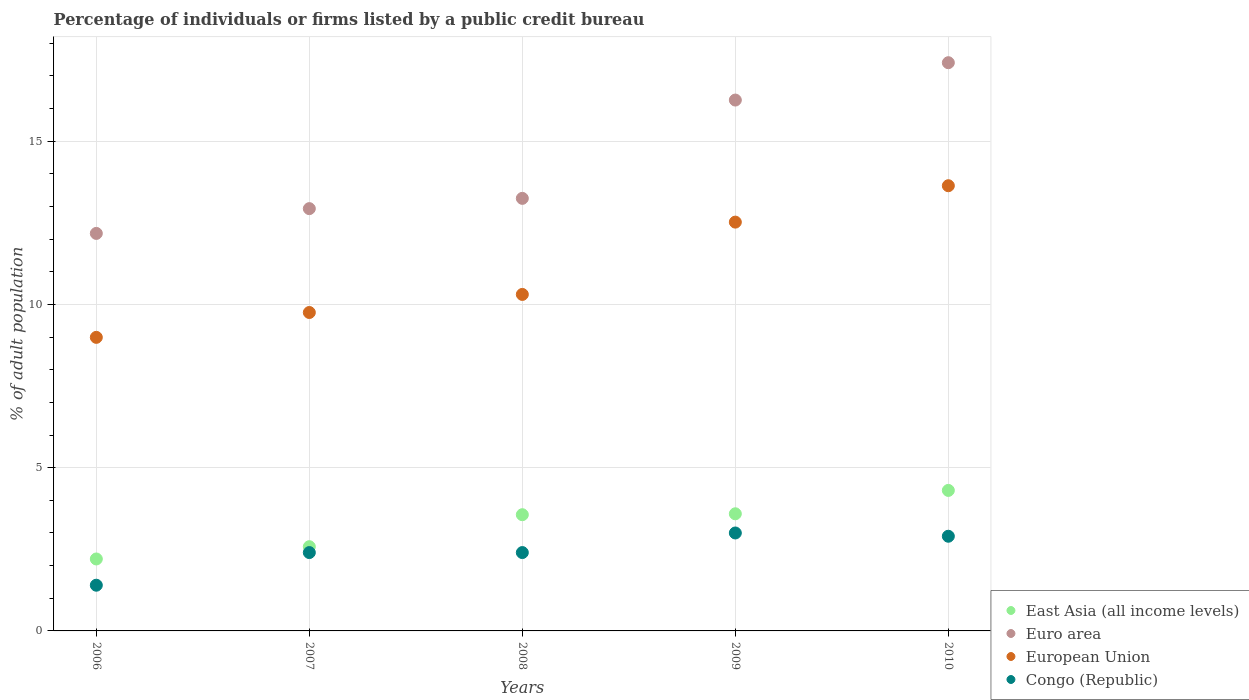What is the percentage of population listed by a public credit bureau in Euro area in 2006?
Offer a terse response. 12.18. Across all years, what is the maximum percentage of population listed by a public credit bureau in Euro area?
Your answer should be very brief. 17.41. In which year was the percentage of population listed by a public credit bureau in East Asia (all income levels) minimum?
Offer a terse response. 2006. What is the total percentage of population listed by a public credit bureau in East Asia (all income levels) in the graph?
Offer a terse response. 16.24. What is the difference between the percentage of population listed by a public credit bureau in Congo (Republic) in 2008 and that in 2010?
Provide a short and direct response. -0.5. What is the difference between the percentage of population listed by a public credit bureau in Congo (Republic) in 2006 and the percentage of population listed by a public credit bureau in European Union in 2008?
Offer a terse response. -8.91. What is the average percentage of population listed by a public credit bureau in European Union per year?
Your response must be concise. 11.04. In the year 2010, what is the difference between the percentage of population listed by a public credit bureau in East Asia (all income levels) and percentage of population listed by a public credit bureau in European Union?
Your answer should be very brief. -9.33. In how many years, is the percentage of population listed by a public credit bureau in Euro area greater than 12 %?
Your response must be concise. 5. What is the ratio of the percentage of population listed by a public credit bureau in Congo (Republic) in 2008 to that in 2010?
Make the answer very short. 0.83. What is the difference between the highest and the second highest percentage of population listed by a public credit bureau in Euro area?
Your answer should be very brief. 1.14. What is the difference between the highest and the lowest percentage of population listed by a public credit bureau in European Union?
Offer a very short reply. 4.64. Is it the case that in every year, the sum of the percentage of population listed by a public credit bureau in European Union and percentage of population listed by a public credit bureau in Euro area  is greater than the sum of percentage of population listed by a public credit bureau in Congo (Republic) and percentage of population listed by a public credit bureau in East Asia (all income levels)?
Provide a succinct answer. No. Is the percentage of population listed by a public credit bureau in European Union strictly less than the percentage of population listed by a public credit bureau in Euro area over the years?
Offer a terse response. Yes. What is the difference between two consecutive major ticks on the Y-axis?
Offer a terse response. 5. Are the values on the major ticks of Y-axis written in scientific E-notation?
Ensure brevity in your answer.  No. Does the graph contain any zero values?
Provide a succinct answer. No. Does the graph contain grids?
Keep it short and to the point. Yes. How many legend labels are there?
Offer a terse response. 4. What is the title of the graph?
Offer a very short reply. Percentage of individuals or firms listed by a public credit bureau. Does "Serbia" appear as one of the legend labels in the graph?
Make the answer very short. No. What is the label or title of the Y-axis?
Make the answer very short. % of adult population. What is the % of adult population of East Asia (all income levels) in 2006?
Your response must be concise. 2.2. What is the % of adult population of Euro area in 2006?
Provide a succinct answer. 12.18. What is the % of adult population of European Union in 2006?
Offer a terse response. 8.99. What is the % of adult population in East Asia (all income levels) in 2007?
Keep it short and to the point. 2.58. What is the % of adult population in Euro area in 2007?
Your response must be concise. 12.94. What is the % of adult population in European Union in 2007?
Ensure brevity in your answer.  9.75. What is the % of adult population in Congo (Republic) in 2007?
Offer a terse response. 2.4. What is the % of adult population of East Asia (all income levels) in 2008?
Keep it short and to the point. 3.56. What is the % of adult population in Euro area in 2008?
Offer a very short reply. 13.25. What is the % of adult population in European Union in 2008?
Your response must be concise. 10.31. What is the % of adult population in Congo (Republic) in 2008?
Your answer should be very brief. 2.4. What is the % of adult population of East Asia (all income levels) in 2009?
Provide a short and direct response. 3.59. What is the % of adult population in Euro area in 2009?
Offer a very short reply. 16.26. What is the % of adult population in European Union in 2009?
Make the answer very short. 12.52. What is the % of adult population in Congo (Republic) in 2009?
Offer a terse response. 3. What is the % of adult population of East Asia (all income levels) in 2010?
Keep it short and to the point. 4.3. What is the % of adult population of Euro area in 2010?
Provide a short and direct response. 17.41. What is the % of adult population of European Union in 2010?
Keep it short and to the point. 13.64. Across all years, what is the maximum % of adult population in East Asia (all income levels)?
Your response must be concise. 4.3. Across all years, what is the maximum % of adult population of Euro area?
Keep it short and to the point. 17.41. Across all years, what is the maximum % of adult population in European Union?
Provide a succinct answer. 13.64. Across all years, what is the minimum % of adult population in East Asia (all income levels)?
Offer a terse response. 2.2. Across all years, what is the minimum % of adult population in Euro area?
Your answer should be very brief. 12.18. Across all years, what is the minimum % of adult population in European Union?
Offer a very short reply. 8.99. Across all years, what is the minimum % of adult population of Congo (Republic)?
Make the answer very short. 1.4. What is the total % of adult population in East Asia (all income levels) in the graph?
Ensure brevity in your answer.  16.24. What is the total % of adult population in Euro area in the graph?
Provide a short and direct response. 72.03. What is the total % of adult population of European Union in the graph?
Offer a terse response. 55.21. What is the total % of adult population in Congo (Republic) in the graph?
Offer a very short reply. 12.1. What is the difference between the % of adult population of East Asia (all income levels) in 2006 and that in 2007?
Provide a short and direct response. -0.38. What is the difference between the % of adult population of Euro area in 2006 and that in 2007?
Your answer should be very brief. -0.76. What is the difference between the % of adult population in European Union in 2006 and that in 2007?
Provide a short and direct response. -0.76. What is the difference between the % of adult population in East Asia (all income levels) in 2006 and that in 2008?
Provide a succinct answer. -1.36. What is the difference between the % of adult population in Euro area in 2006 and that in 2008?
Provide a succinct answer. -1.07. What is the difference between the % of adult population in European Union in 2006 and that in 2008?
Give a very brief answer. -1.32. What is the difference between the % of adult population in East Asia (all income levels) in 2006 and that in 2009?
Provide a succinct answer. -1.38. What is the difference between the % of adult population in Euro area in 2006 and that in 2009?
Offer a very short reply. -4.08. What is the difference between the % of adult population in European Union in 2006 and that in 2009?
Your answer should be very brief. -3.53. What is the difference between the % of adult population in Congo (Republic) in 2006 and that in 2009?
Your answer should be compact. -1.6. What is the difference between the % of adult population in Euro area in 2006 and that in 2010?
Offer a very short reply. -5.23. What is the difference between the % of adult population of European Union in 2006 and that in 2010?
Ensure brevity in your answer.  -4.64. What is the difference between the % of adult population of Congo (Republic) in 2006 and that in 2010?
Provide a succinct answer. -1.5. What is the difference between the % of adult population of East Asia (all income levels) in 2007 and that in 2008?
Give a very brief answer. -0.98. What is the difference between the % of adult population in Euro area in 2007 and that in 2008?
Offer a very short reply. -0.31. What is the difference between the % of adult population of European Union in 2007 and that in 2008?
Your answer should be compact. -0.55. What is the difference between the % of adult population of East Asia (all income levels) in 2007 and that in 2009?
Your response must be concise. -1.01. What is the difference between the % of adult population in Euro area in 2007 and that in 2009?
Keep it short and to the point. -3.33. What is the difference between the % of adult population of European Union in 2007 and that in 2009?
Give a very brief answer. -2.77. What is the difference between the % of adult population in Congo (Republic) in 2007 and that in 2009?
Make the answer very short. -0.6. What is the difference between the % of adult population of East Asia (all income levels) in 2007 and that in 2010?
Your answer should be very brief. -1.72. What is the difference between the % of adult population of Euro area in 2007 and that in 2010?
Keep it short and to the point. -4.47. What is the difference between the % of adult population of European Union in 2007 and that in 2010?
Keep it short and to the point. -3.88. What is the difference between the % of adult population in East Asia (all income levels) in 2008 and that in 2009?
Offer a very short reply. -0.03. What is the difference between the % of adult population in Euro area in 2008 and that in 2009?
Offer a terse response. -3.01. What is the difference between the % of adult population of European Union in 2008 and that in 2009?
Offer a very short reply. -2.21. What is the difference between the % of adult population in East Asia (all income levels) in 2008 and that in 2010?
Provide a short and direct response. -0.74. What is the difference between the % of adult population of Euro area in 2008 and that in 2010?
Offer a very short reply. -4.16. What is the difference between the % of adult population in European Union in 2008 and that in 2010?
Give a very brief answer. -3.33. What is the difference between the % of adult population of East Asia (all income levels) in 2009 and that in 2010?
Your response must be concise. -0.72. What is the difference between the % of adult population in Euro area in 2009 and that in 2010?
Provide a short and direct response. -1.14. What is the difference between the % of adult population in European Union in 2009 and that in 2010?
Your answer should be compact. -1.11. What is the difference between the % of adult population in Congo (Republic) in 2009 and that in 2010?
Ensure brevity in your answer.  0.1. What is the difference between the % of adult population in East Asia (all income levels) in 2006 and the % of adult population in Euro area in 2007?
Your answer should be compact. -10.73. What is the difference between the % of adult population of East Asia (all income levels) in 2006 and the % of adult population of European Union in 2007?
Keep it short and to the point. -7.55. What is the difference between the % of adult population in East Asia (all income levels) in 2006 and the % of adult population in Congo (Republic) in 2007?
Provide a short and direct response. -0.2. What is the difference between the % of adult population of Euro area in 2006 and the % of adult population of European Union in 2007?
Ensure brevity in your answer.  2.42. What is the difference between the % of adult population of Euro area in 2006 and the % of adult population of Congo (Republic) in 2007?
Make the answer very short. 9.78. What is the difference between the % of adult population of European Union in 2006 and the % of adult population of Congo (Republic) in 2007?
Provide a short and direct response. 6.59. What is the difference between the % of adult population in East Asia (all income levels) in 2006 and the % of adult population in Euro area in 2008?
Your response must be concise. -11.05. What is the difference between the % of adult population in East Asia (all income levels) in 2006 and the % of adult population in European Union in 2008?
Your answer should be compact. -8.1. What is the difference between the % of adult population in East Asia (all income levels) in 2006 and the % of adult population in Congo (Republic) in 2008?
Offer a very short reply. -0.2. What is the difference between the % of adult population in Euro area in 2006 and the % of adult population in European Union in 2008?
Your answer should be compact. 1.87. What is the difference between the % of adult population in Euro area in 2006 and the % of adult population in Congo (Republic) in 2008?
Provide a short and direct response. 9.78. What is the difference between the % of adult population of European Union in 2006 and the % of adult population of Congo (Republic) in 2008?
Make the answer very short. 6.59. What is the difference between the % of adult population of East Asia (all income levels) in 2006 and the % of adult population of Euro area in 2009?
Your answer should be compact. -14.06. What is the difference between the % of adult population of East Asia (all income levels) in 2006 and the % of adult population of European Union in 2009?
Give a very brief answer. -10.32. What is the difference between the % of adult population in East Asia (all income levels) in 2006 and the % of adult population in Congo (Republic) in 2009?
Your response must be concise. -0.8. What is the difference between the % of adult population of Euro area in 2006 and the % of adult population of European Union in 2009?
Keep it short and to the point. -0.35. What is the difference between the % of adult population in Euro area in 2006 and the % of adult population in Congo (Republic) in 2009?
Your answer should be compact. 9.18. What is the difference between the % of adult population in European Union in 2006 and the % of adult population in Congo (Republic) in 2009?
Provide a short and direct response. 5.99. What is the difference between the % of adult population in East Asia (all income levels) in 2006 and the % of adult population in Euro area in 2010?
Ensure brevity in your answer.  -15.2. What is the difference between the % of adult population in East Asia (all income levels) in 2006 and the % of adult population in European Union in 2010?
Provide a short and direct response. -11.43. What is the difference between the % of adult population in East Asia (all income levels) in 2006 and the % of adult population in Congo (Republic) in 2010?
Make the answer very short. -0.7. What is the difference between the % of adult population in Euro area in 2006 and the % of adult population in European Union in 2010?
Your answer should be very brief. -1.46. What is the difference between the % of adult population in Euro area in 2006 and the % of adult population in Congo (Republic) in 2010?
Keep it short and to the point. 9.28. What is the difference between the % of adult population in European Union in 2006 and the % of adult population in Congo (Republic) in 2010?
Offer a very short reply. 6.09. What is the difference between the % of adult population in East Asia (all income levels) in 2007 and the % of adult population in Euro area in 2008?
Your answer should be very brief. -10.67. What is the difference between the % of adult population of East Asia (all income levels) in 2007 and the % of adult population of European Union in 2008?
Your response must be concise. -7.73. What is the difference between the % of adult population of East Asia (all income levels) in 2007 and the % of adult population of Congo (Republic) in 2008?
Provide a succinct answer. 0.18. What is the difference between the % of adult population in Euro area in 2007 and the % of adult population in European Union in 2008?
Your answer should be compact. 2.63. What is the difference between the % of adult population in Euro area in 2007 and the % of adult population in Congo (Republic) in 2008?
Your answer should be compact. 10.54. What is the difference between the % of adult population in European Union in 2007 and the % of adult population in Congo (Republic) in 2008?
Give a very brief answer. 7.35. What is the difference between the % of adult population in East Asia (all income levels) in 2007 and the % of adult population in Euro area in 2009?
Provide a succinct answer. -13.68. What is the difference between the % of adult population of East Asia (all income levels) in 2007 and the % of adult population of European Union in 2009?
Give a very brief answer. -9.94. What is the difference between the % of adult population in East Asia (all income levels) in 2007 and the % of adult population in Congo (Republic) in 2009?
Your answer should be compact. -0.42. What is the difference between the % of adult population of Euro area in 2007 and the % of adult population of European Union in 2009?
Provide a short and direct response. 0.41. What is the difference between the % of adult population in Euro area in 2007 and the % of adult population in Congo (Republic) in 2009?
Offer a very short reply. 9.94. What is the difference between the % of adult population of European Union in 2007 and the % of adult population of Congo (Republic) in 2009?
Your response must be concise. 6.75. What is the difference between the % of adult population in East Asia (all income levels) in 2007 and the % of adult population in Euro area in 2010?
Keep it short and to the point. -14.83. What is the difference between the % of adult population of East Asia (all income levels) in 2007 and the % of adult population of European Union in 2010?
Make the answer very short. -11.06. What is the difference between the % of adult population of East Asia (all income levels) in 2007 and the % of adult population of Congo (Republic) in 2010?
Your response must be concise. -0.32. What is the difference between the % of adult population in Euro area in 2007 and the % of adult population in European Union in 2010?
Your response must be concise. -0.7. What is the difference between the % of adult population of Euro area in 2007 and the % of adult population of Congo (Republic) in 2010?
Offer a terse response. 10.04. What is the difference between the % of adult population in European Union in 2007 and the % of adult population in Congo (Republic) in 2010?
Your answer should be compact. 6.85. What is the difference between the % of adult population of East Asia (all income levels) in 2008 and the % of adult population of Euro area in 2009?
Make the answer very short. -12.7. What is the difference between the % of adult population in East Asia (all income levels) in 2008 and the % of adult population in European Union in 2009?
Make the answer very short. -8.96. What is the difference between the % of adult population in East Asia (all income levels) in 2008 and the % of adult population in Congo (Republic) in 2009?
Your answer should be very brief. 0.56. What is the difference between the % of adult population of Euro area in 2008 and the % of adult population of European Union in 2009?
Your answer should be very brief. 0.73. What is the difference between the % of adult population of Euro area in 2008 and the % of adult population of Congo (Republic) in 2009?
Offer a very short reply. 10.25. What is the difference between the % of adult population in European Union in 2008 and the % of adult population in Congo (Republic) in 2009?
Provide a short and direct response. 7.31. What is the difference between the % of adult population in East Asia (all income levels) in 2008 and the % of adult population in Euro area in 2010?
Ensure brevity in your answer.  -13.85. What is the difference between the % of adult population in East Asia (all income levels) in 2008 and the % of adult population in European Union in 2010?
Provide a succinct answer. -10.08. What is the difference between the % of adult population in East Asia (all income levels) in 2008 and the % of adult population in Congo (Republic) in 2010?
Provide a short and direct response. 0.66. What is the difference between the % of adult population of Euro area in 2008 and the % of adult population of European Union in 2010?
Offer a terse response. -0.39. What is the difference between the % of adult population of Euro area in 2008 and the % of adult population of Congo (Republic) in 2010?
Ensure brevity in your answer.  10.35. What is the difference between the % of adult population in European Union in 2008 and the % of adult population in Congo (Republic) in 2010?
Ensure brevity in your answer.  7.41. What is the difference between the % of adult population of East Asia (all income levels) in 2009 and the % of adult population of Euro area in 2010?
Provide a short and direct response. -13.82. What is the difference between the % of adult population of East Asia (all income levels) in 2009 and the % of adult population of European Union in 2010?
Give a very brief answer. -10.05. What is the difference between the % of adult population in East Asia (all income levels) in 2009 and the % of adult population in Congo (Republic) in 2010?
Offer a very short reply. 0.69. What is the difference between the % of adult population of Euro area in 2009 and the % of adult population of European Union in 2010?
Make the answer very short. 2.62. What is the difference between the % of adult population of Euro area in 2009 and the % of adult population of Congo (Republic) in 2010?
Provide a short and direct response. 13.36. What is the difference between the % of adult population in European Union in 2009 and the % of adult population in Congo (Republic) in 2010?
Offer a very short reply. 9.62. What is the average % of adult population in East Asia (all income levels) per year?
Offer a very short reply. 3.25. What is the average % of adult population of Euro area per year?
Your answer should be very brief. 14.41. What is the average % of adult population in European Union per year?
Your response must be concise. 11.04. What is the average % of adult population in Congo (Republic) per year?
Your answer should be compact. 2.42. In the year 2006, what is the difference between the % of adult population of East Asia (all income levels) and % of adult population of Euro area?
Offer a very short reply. -9.97. In the year 2006, what is the difference between the % of adult population of East Asia (all income levels) and % of adult population of European Union?
Give a very brief answer. -6.79. In the year 2006, what is the difference between the % of adult population of East Asia (all income levels) and % of adult population of Congo (Republic)?
Your response must be concise. 0.8. In the year 2006, what is the difference between the % of adult population of Euro area and % of adult population of European Union?
Provide a succinct answer. 3.18. In the year 2006, what is the difference between the % of adult population in Euro area and % of adult population in Congo (Republic)?
Make the answer very short. 10.78. In the year 2006, what is the difference between the % of adult population in European Union and % of adult population in Congo (Republic)?
Your answer should be very brief. 7.59. In the year 2007, what is the difference between the % of adult population of East Asia (all income levels) and % of adult population of Euro area?
Your answer should be compact. -10.36. In the year 2007, what is the difference between the % of adult population in East Asia (all income levels) and % of adult population in European Union?
Provide a short and direct response. -7.17. In the year 2007, what is the difference between the % of adult population of East Asia (all income levels) and % of adult population of Congo (Republic)?
Make the answer very short. 0.18. In the year 2007, what is the difference between the % of adult population in Euro area and % of adult population in European Union?
Provide a short and direct response. 3.18. In the year 2007, what is the difference between the % of adult population in Euro area and % of adult population in Congo (Republic)?
Make the answer very short. 10.54. In the year 2007, what is the difference between the % of adult population of European Union and % of adult population of Congo (Republic)?
Offer a very short reply. 7.35. In the year 2008, what is the difference between the % of adult population in East Asia (all income levels) and % of adult population in Euro area?
Give a very brief answer. -9.69. In the year 2008, what is the difference between the % of adult population in East Asia (all income levels) and % of adult population in European Union?
Keep it short and to the point. -6.75. In the year 2008, what is the difference between the % of adult population in East Asia (all income levels) and % of adult population in Congo (Republic)?
Your answer should be compact. 1.16. In the year 2008, what is the difference between the % of adult population in Euro area and % of adult population in European Union?
Provide a short and direct response. 2.94. In the year 2008, what is the difference between the % of adult population in Euro area and % of adult population in Congo (Republic)?
Your answer should be compact. 10.85. In the year 2008, what is the difference between the % of adult population of European Union and % of adult population of Congo (Republic)?
Your response must be concise. 7.91. In the year 2009, what is the difference between the % of adult population in East Asia (all income levels) and % of adult population in Euro area?
Your answer should be very brief. -12.67. In the year 2009, what is the difference between the % of adult population in East Asia (all income levels) and % of adult population in European Union?
Offer a very short reply. -8.93. In the year 2009, what is the difference between the % of adult population in East Asia (all income levels) and % of adult population in Congo (Republic)?
Provide a short and direct response. 0.59. In the year 2009, what is the difference between the % of adult population of Euro area and % of adult population of European Union?
Offer a very short reply. 3.74. In the year 2009, what is the difference between the % of adult population of Euro area and % of adult population of Congo (Republic)?
Provide a short and direct response. 13.26. In the year 2009, what is the difference between the % of adult population of European Union and % of adult population of Congo (Republic)?
Ensure brevity in your answer.  9.52. In the year 2010, what is the difference between the % of adult population in East Asia (all income levels) and % of adult population in Euro area?
Give a very brief answer. -13.1. In the year 2010, what is the difference between the % of adult population in East Asia (all income levels) and % of adult population in European Union?
Give a very brief answer. -9.33. In the year 2010, what is the difference between the % of adult population of East Asia (all income levels) and % of adult population of Congo (Republic)?
Ensure brevity in your answer.  1.4. In the year 2010, what is the difference between the % of adult population of Euro area and % of adult population of European Union?
Offer a terse response. 3.77. In the year 2010, what is the difference between the % of adult population in Euro area and % of adult population in Congo (Republic)?
Keep it short and to the point. 14.51. In the year 2010, what is the difference between the % of adult population in European Union and % of adult population in Congo (Republic)?
Offer a very short reply. 10.74. What is the ratio of the % of adult population of East Asia (all income levels) in 2006 to that in 2007?
Make the answer very short. 0.85. What is the ratio of the % of adult population in Euro area in 2006 to that in 2007?
Provide a short and direct response. 0.94. What is the ratio of the % of adult population of European Union in 2006 to that in 2007?
Offer a very short reply. 0.92. What is the ratio of the % of adult population of Congo (Republic) in 2006 to that in 2007?
Your answer should be very brief. 0.58. What is the ratio of the % of adult population in East Asia (all income levels) in 2006 to that in 2008?
Keep it short and to the point. 0.62. What is the ratio of the % of adult population in Euro area in 2006 to that in 2008?
Provide a succinct answer. 0.92. What is the ratio of the % of adult population in European Union in 2006 to that in 2008?
Offer a terse response. 0.87. What is the ratio of the % of adult population in Congo (Republic) in 2006 to that in 2008?
Offer a terse response. 0.58. What is the ratio of the % of adult population of East Asia (all income levels) in 2006 to that in 2009?
Provide a short and direct response. 0.61. What is the ratio of the % of adult population in Euro area in 2006 to that in 2009?
Ensure brevity in your answer.  0.75. What is the ratio of the % of adult population of European Union in 2006 to that in 2009?
Your response must be concise. 0.72. What is the ratio of the % of adult population of Congo (Republic) in 2006 to that in 2009?
Provide a short and direct response. 0.47. What is the ratio of the % of adult population of East Asia (all income levels) in 2006 to that in 2010?
Ensure brevity in your answer.  0.51. What is the ratio of the % of adult population in Euro area in 2006 to that in 2010?
Ensure brevity in your answer.  0.7. What is the ratio of the % of adult population of European Union in 2006 to that in 2010?
Offer a terse response. 0.66. What is the ratio of the % of adult population of Congo (Republic) in 2006 to that in 2010?
Keep it short and to the point. 0.48. What is the ratio of the % of adult population in East Asia (all income levels) in 2007 to that in 2008?
Your answer should be very brief. 0.72. What is the ratio of the % of adult population in Euro area in 2007 to that in 2008?
Your answer should be compact. 0.98. What is the ratio of the % of adult population of European Union in 2007 to that in 2008?
Your answer should be very brief. 0.95. What is the ratio of the % of adult population of Congo (Republic) in 2007 to that in 2008?
Your answer should be very brief. 1. What is the ratio of the % of adult population of East Asia (all income levels) in 2007 to that in 2009?
Offer a terse response. 0.72. What is the ratio of the % of adult population of Euro area in 2007 to that in 2009?
Provide a short and direct response. 0.8. What is the ratio of the % of adult population in European Union in 2007 to that in 2009?
Your answer should be compact. 0.78. What is the ratio of the % of adult population in East Asia (all income levels) in 2007 to that in 2010?
Offer a terse response. 0.6. What is the ratio of the % of adult population in Euro area in 2007 to that in 2010?
Offer a terse response. 0.74. What is the ratio of the % of adult population in European Union in 2007 to that in 2010?
Give a very brief answer. 0.72. What is the ratio of the % of adult population of Congo (Republic) in 2007 to that in 2010?
Give a very brief answer. 0.83. What is the ratio of the % of adult population in East Asia (all income levels) in 2008 to that in 2009?
Make the answer very short. 0.99. What is the ratio of the % of adult population of Euro area in 2008 to that in 2009?
Offer a terse response. 0.81. What is the ratio of the % of adult population of European Union in 2008 to that in 2009?
Your answer should be very brief. 0.82. What is the ratio of the % of adult population in East Asia (all income levels) in 2008 to that in 2010?
Provide a short and direct response. 0.83. What is the ratio of the % of adult population of Euro area in 2008 to that in 2010?
Offer a very short reply. 0.76. What is the ratio of the % of adult population in European Union in 2008 to that in 2010?
Ensure brevity in your answer.  0.76. What is the ratio of the % of adult population of Congo (Republic) in 2008 to that in 2010?
Offer a terse response. 0.83. What is the ratio of the % of adult population in East Asia (all income levels) in 2009 to that in 2010?
Ensure brevity in your answer.  0.83. What is the ratio of the % of adult population in Euro area in 2009 to that in 2010?
Provide a short and direct response. 0.93. What is the ratio of the % of adult population in European Union in 2009 to that in 2010?
Offer a terse response. 0.92. What is the ratio of the % of adult population in Congo (Republic) in 2009 to that in 2010?
Offer a very short reply. 1.03. What is the difference between the highest and the second highest % of adult population of East Asia (all income levels)?
Your answer should be compact. 0.72. What is the difference between the highest and the second highest % of adult population in Euro area?
Offer a very short reply. 1.14. What is the difference between the highest and the second highest % of adult population of European Union?
Ensure brevity in your answer.  1.11. What is the difference between the highest and the second highest % of adult population in Congo (Republic)?
Ensure brevity in your answer.  0.1. What is the difference between the highest and the lowest % of adult population in East Asia (all income levels)?
Your answer should be compact. 2.1. What is the difference between the highest and the lowest % of adult population in Euro area?
Offer a terse response. 5.23. What is the difference between the highest and the lowest % of adult population in European Union?
Offer a terse response. 4.64. 